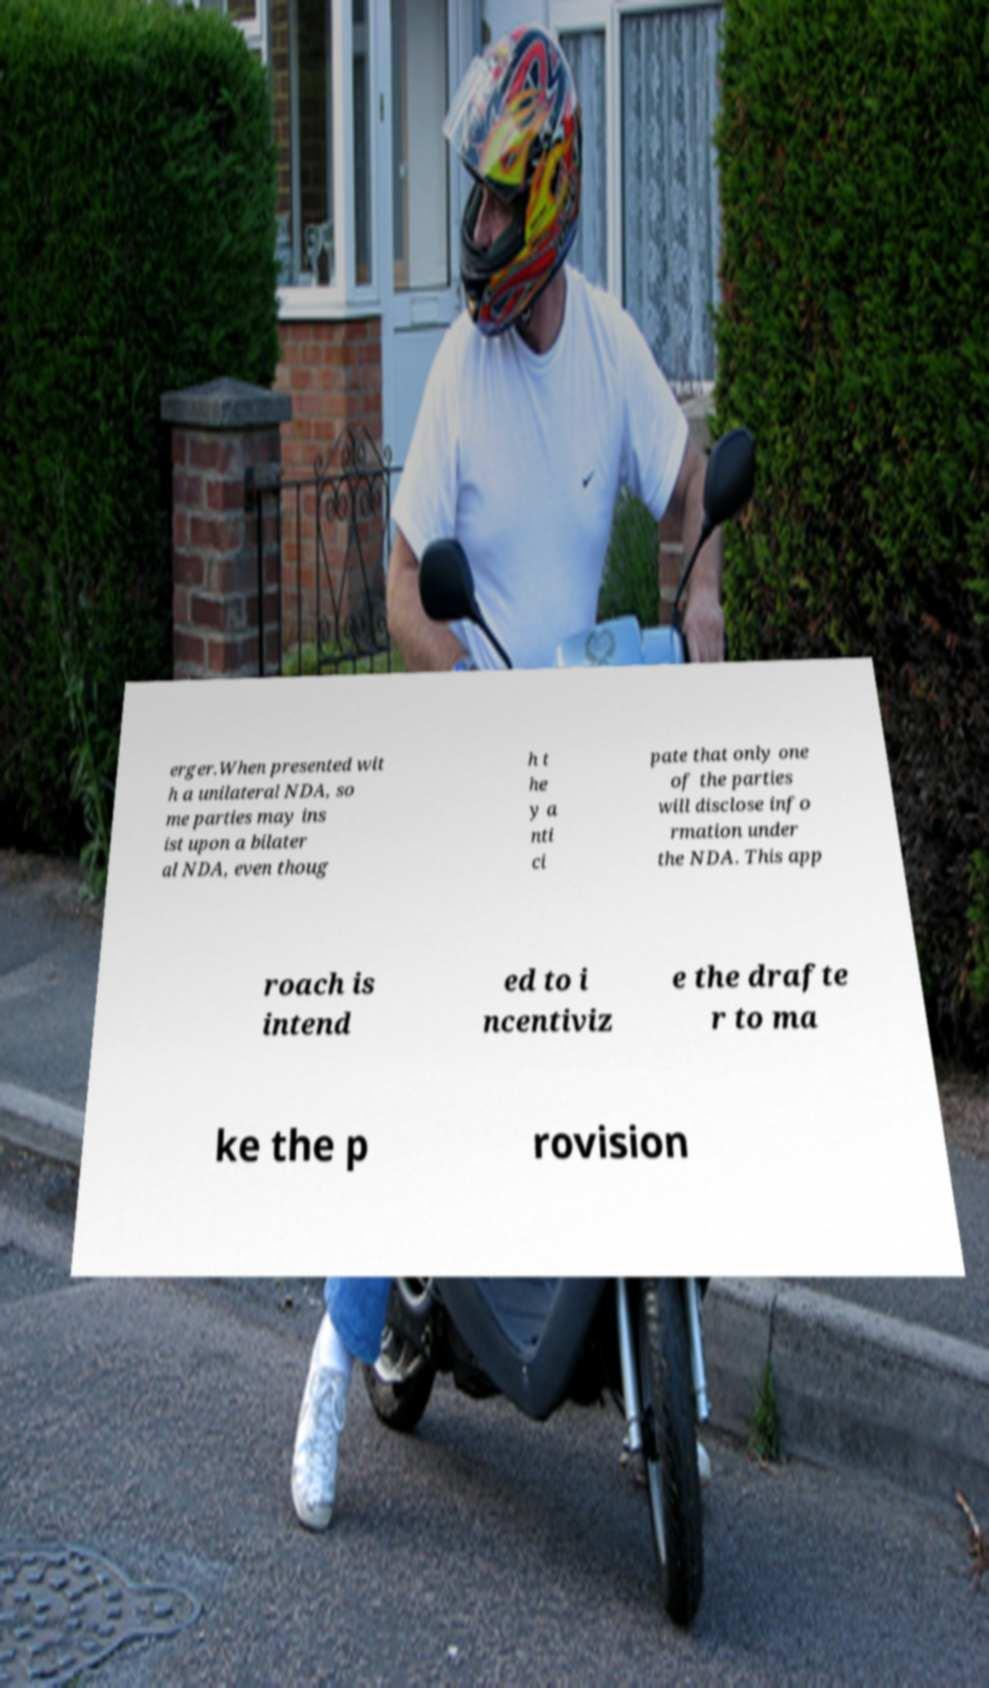Please read and relay the text visible in this image. What does it say? erger.When presented wit h a unilateral NDA, so me parties may ins ist upon a bilater al NDA, even thoug h t he y a nti ci pate that only one of the parties will disclose info rmation under the NDA. This app roach is intend ed to i ncentiviz e the drafte r to ma ke the p rovision 